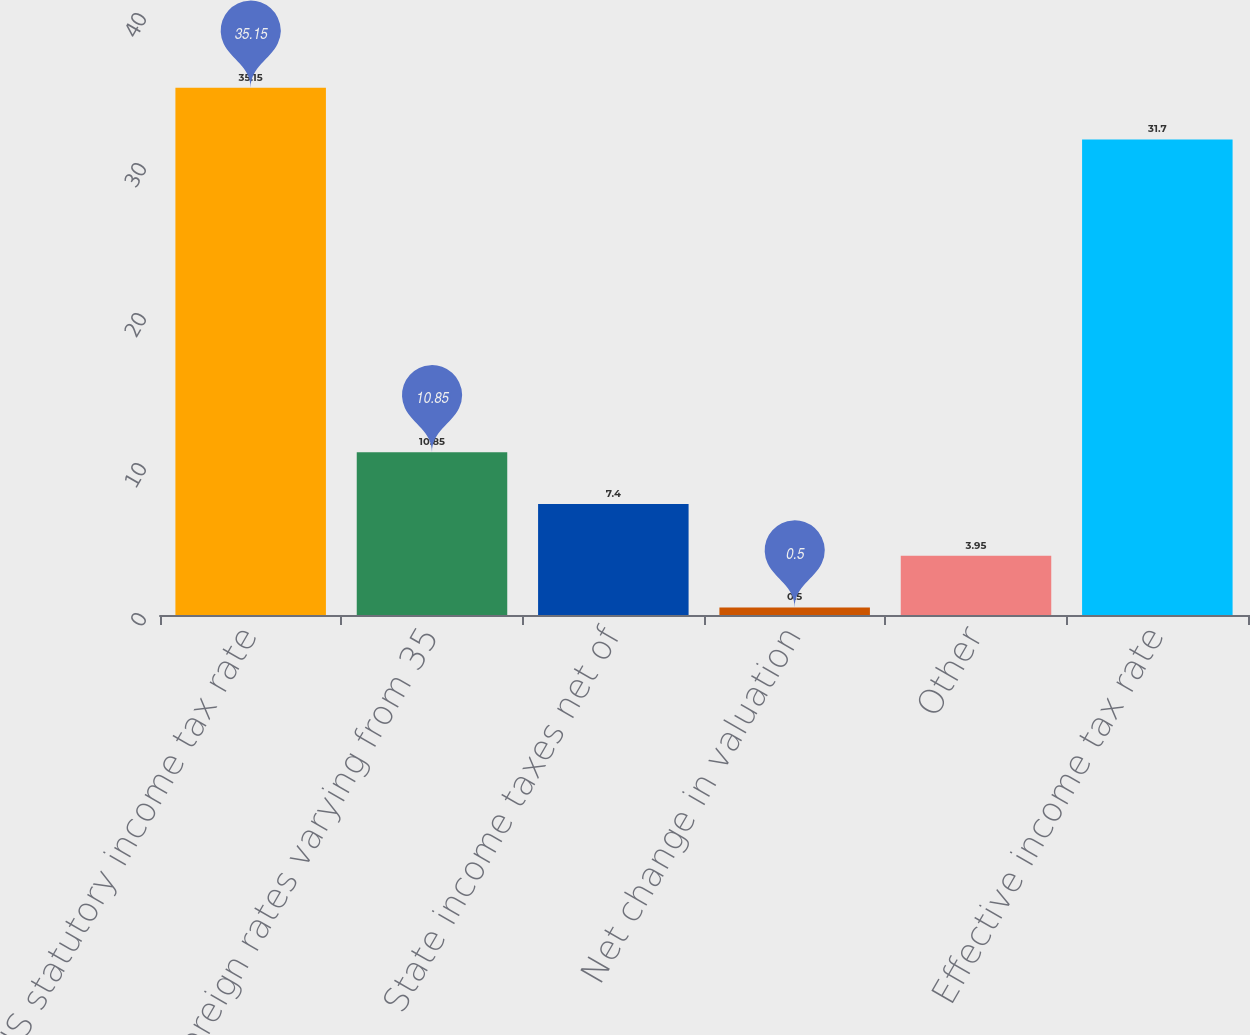Convert chart. <chart><loc_0><loc_0><loc_500><loc_500><bar_chart><fcel>US statutory income tax rate<fcel>Foreign rates varying from 35<fcel>State income taxes net of<fcel>Net change in valuation<fcel>Other<fcel>Effective income tax rate<nl><fcel>35.15<fcel>10.85<fcel>7.4<fcel>0.5<fcel>3.95<fcel>31.7<nl></chart> 